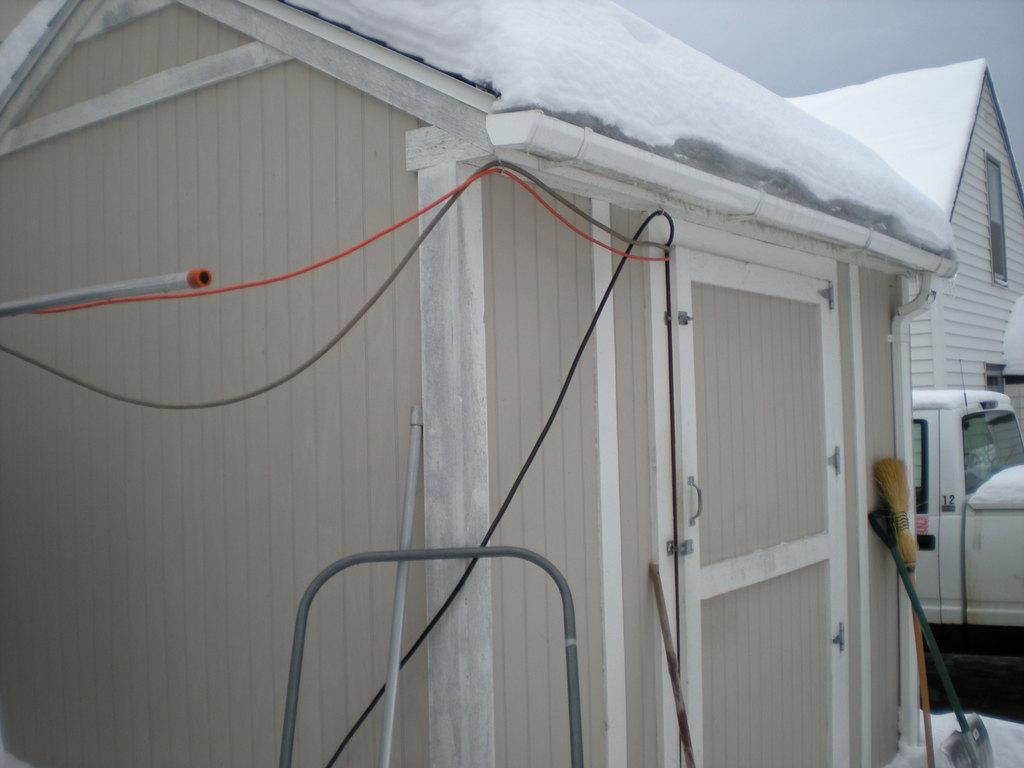How would you summarize this image in a sentence or two? In the image I can see houses, wires, vehicles and some other objects. 